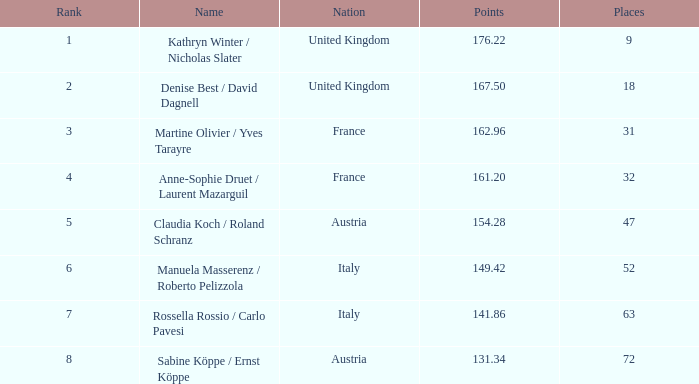Who holds points above 16 Kathryn Winter / Nicholas Slater. 